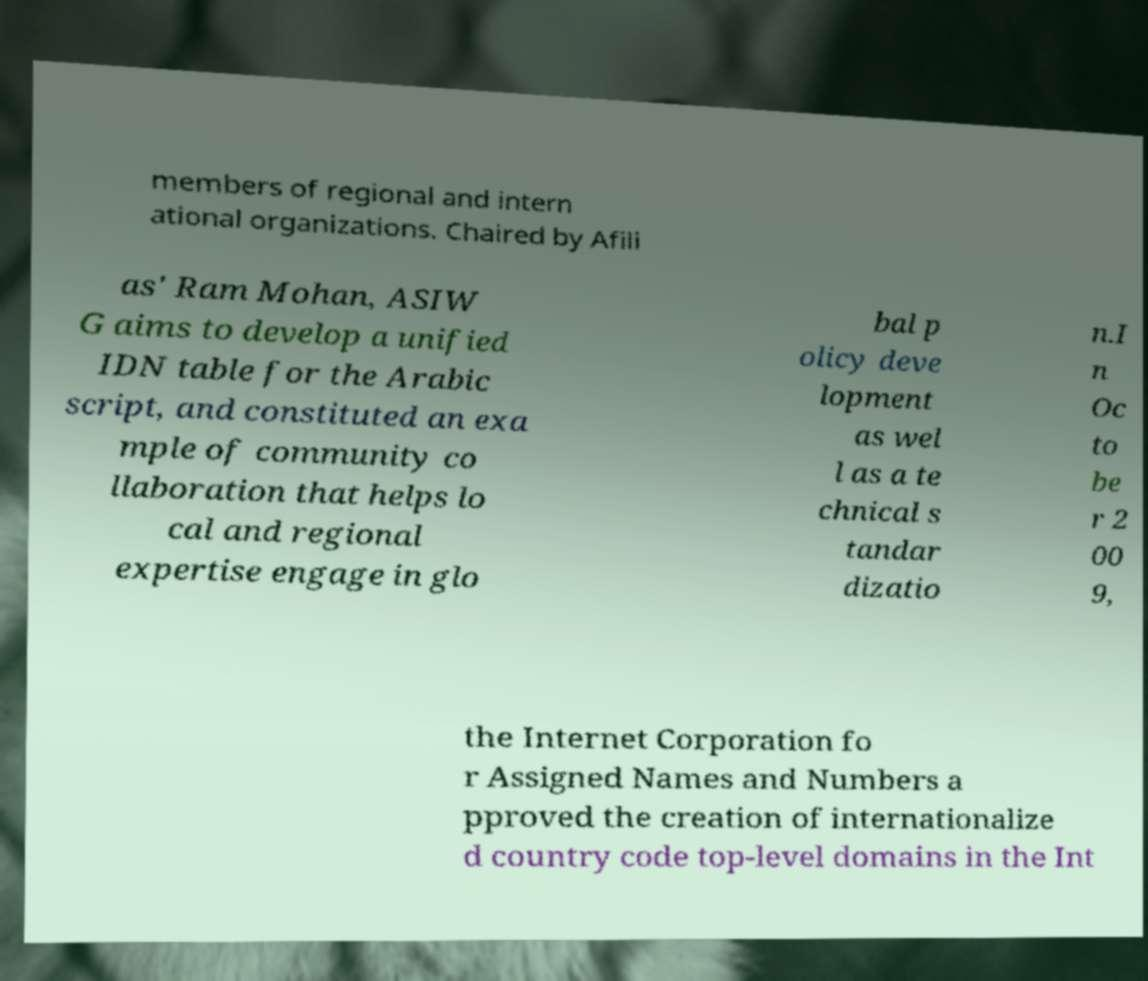I need the written content from this picture converted into text. Can you do that? members of regional and intern ational organizations. Chaired by Afili as' Ram Mohan, ASIW G aims to develop a unified IDN table for the Arabic script, and constituted an exa mple of community co llaboration that helps lo cal and regional expertise engage in glo bal p olicy deve lopment as wel l as a te chnical s tandar dizatio n.I n Oc to be r 2 00 9, the Internet Corporation fo r Assigned Names and Numbers a pproved the creation of internationalize d country code top-level domains in the Int 